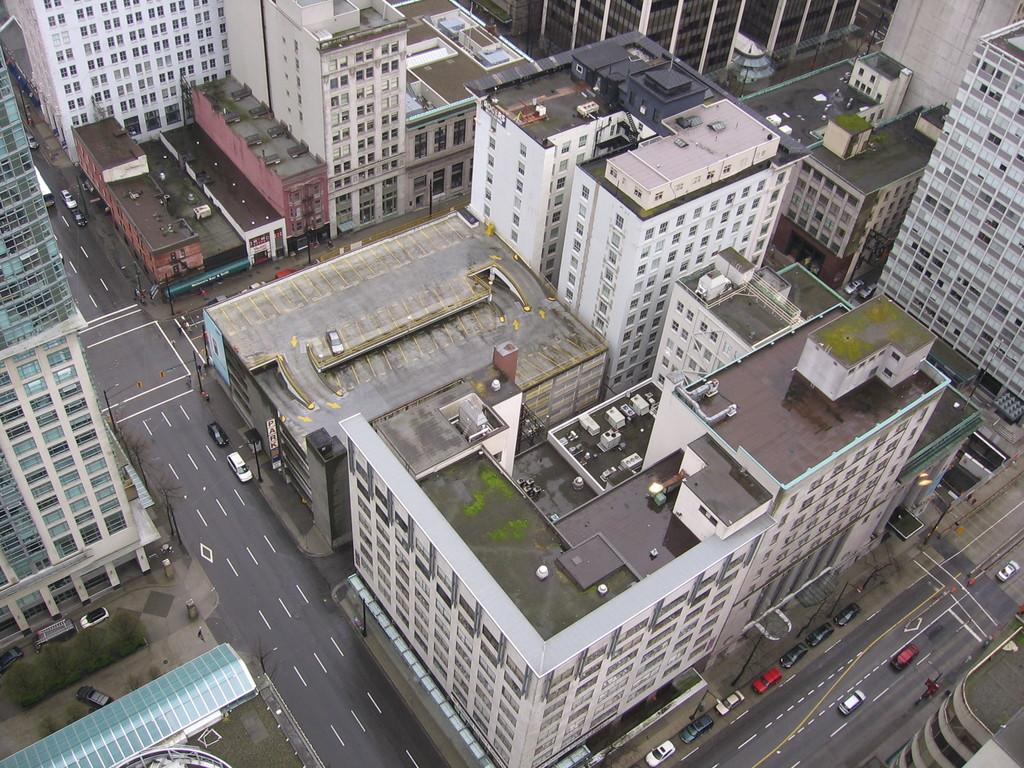What type of structure is present in the image? There is a building in the image. What is located near the building? There is a road in the image. What can be seen on the road? There are cars on the road. What feature is present in the building? There is a window in the building. What objects are visible in the image? There are glasses visible in the image. How many trees are present in the image? There are no trees visible in the image. What degree of difficulty is associated with the task being performed in the image? There is no task being performed in the image, so it's not possible to determine the degree of difficulty. 